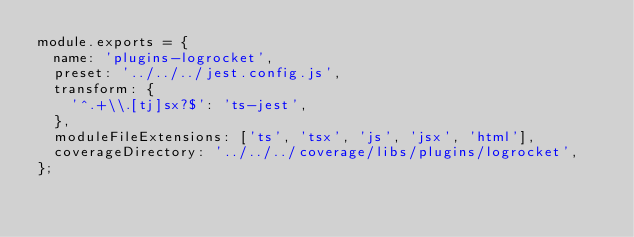<code> <loc_0><loc_0><loc_500><loc_500><_JavaScript_>module.exports = {
  name: 'plugins-logrocket',
  preset: '../../../jest.config.js',
  transform: {
    '^.+\\.[tj]sx?$': 'ts-jest',
  },
  moduleFileExtensions: ['ts', 'tsx', 'js', 'jsx', 'html'],
  coverageDirectory: '../../../coverage/libs/plugins/logrocket',
};
</code> 